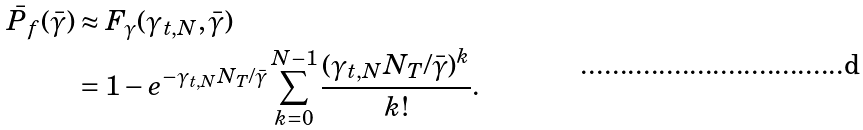<formula> <loc_0><loc_0><loc_500><loc_500>\bar { P } _ { f } ( \bar { \gamma } ) & \approx F _ { \gamma } ( \gamma _ { t , N } , \bar { \gamma } ) \\ & = 1 - e ^ { - \gamma _ { t , N } N _ { T } / \bar { \gamma } } \sum _ { k = 0 } ^ { N - 1 } \frac { ( \gamma _ { t , N } N _ { T } / \bar { \gamma } ) ^ { k } } { k ! } .</formula> 